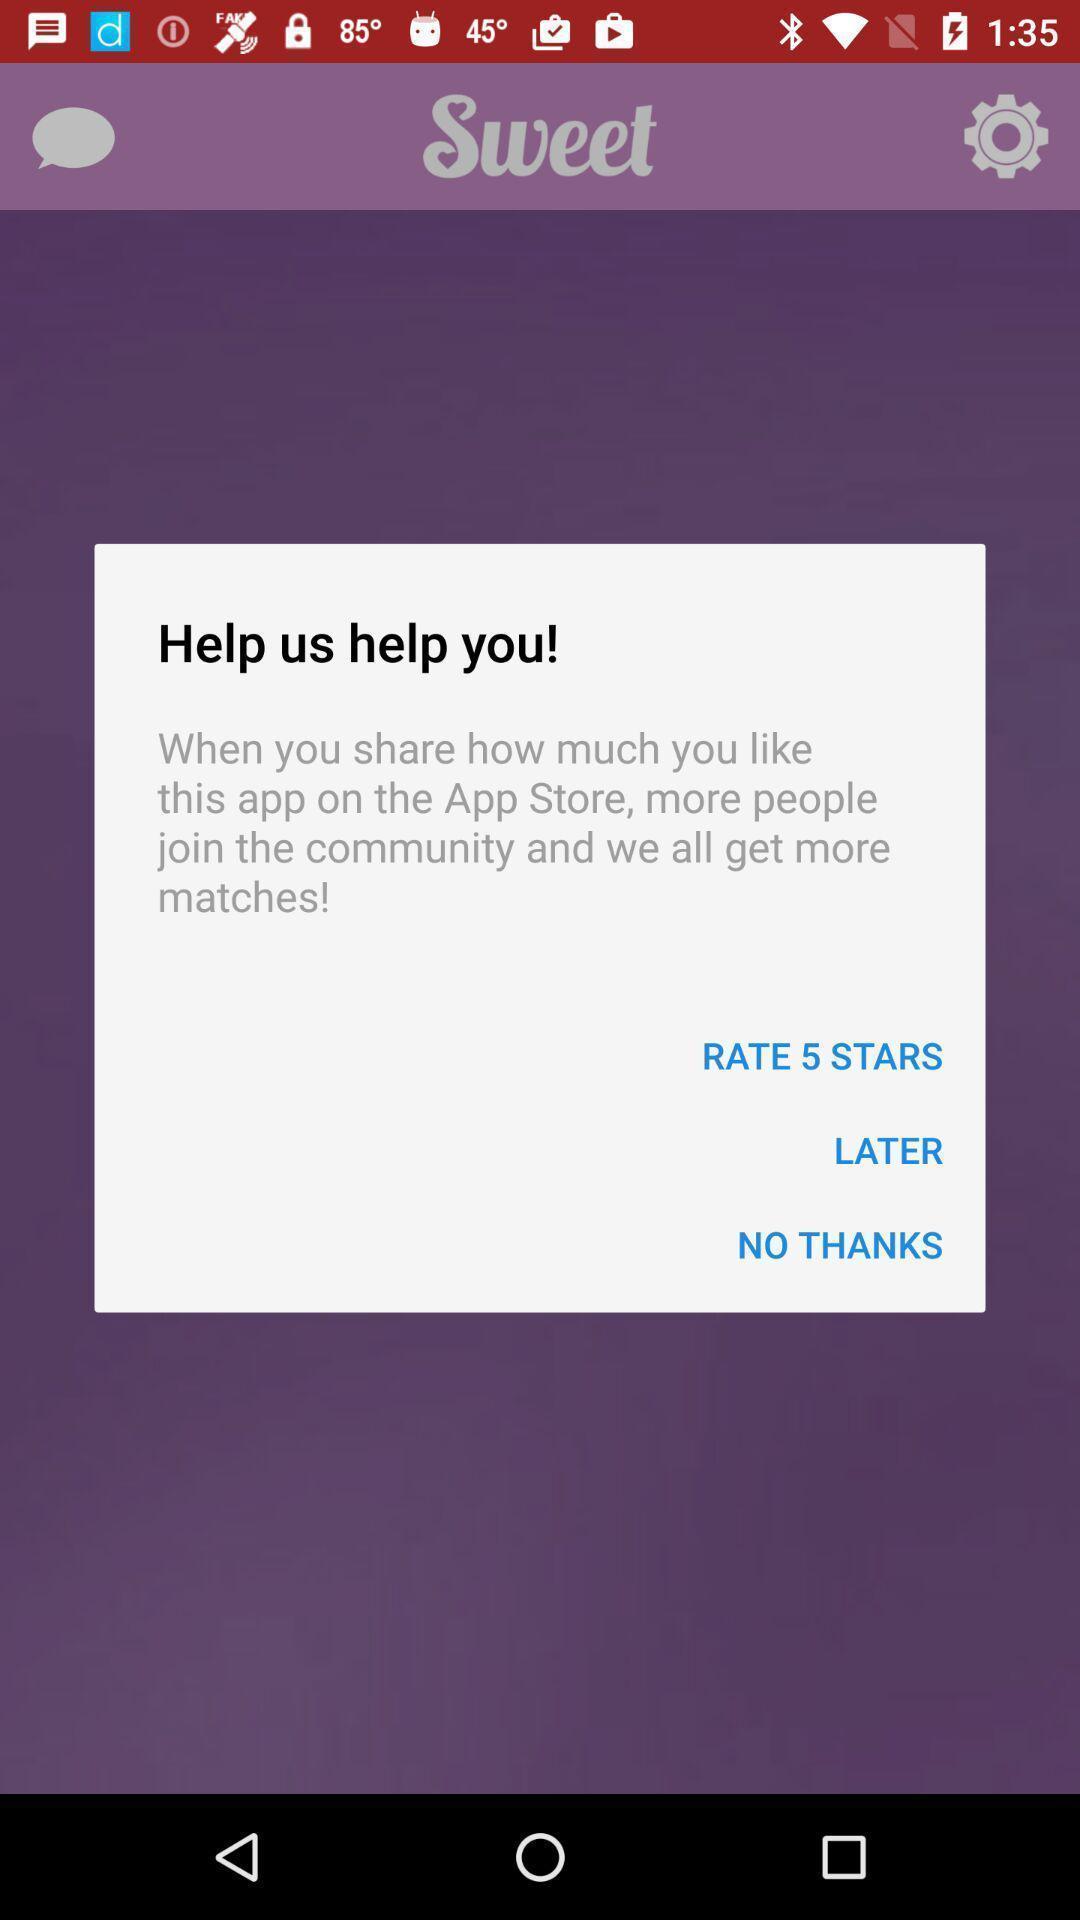Tell me what you see in this picture. Pop-up to rate app experience. 